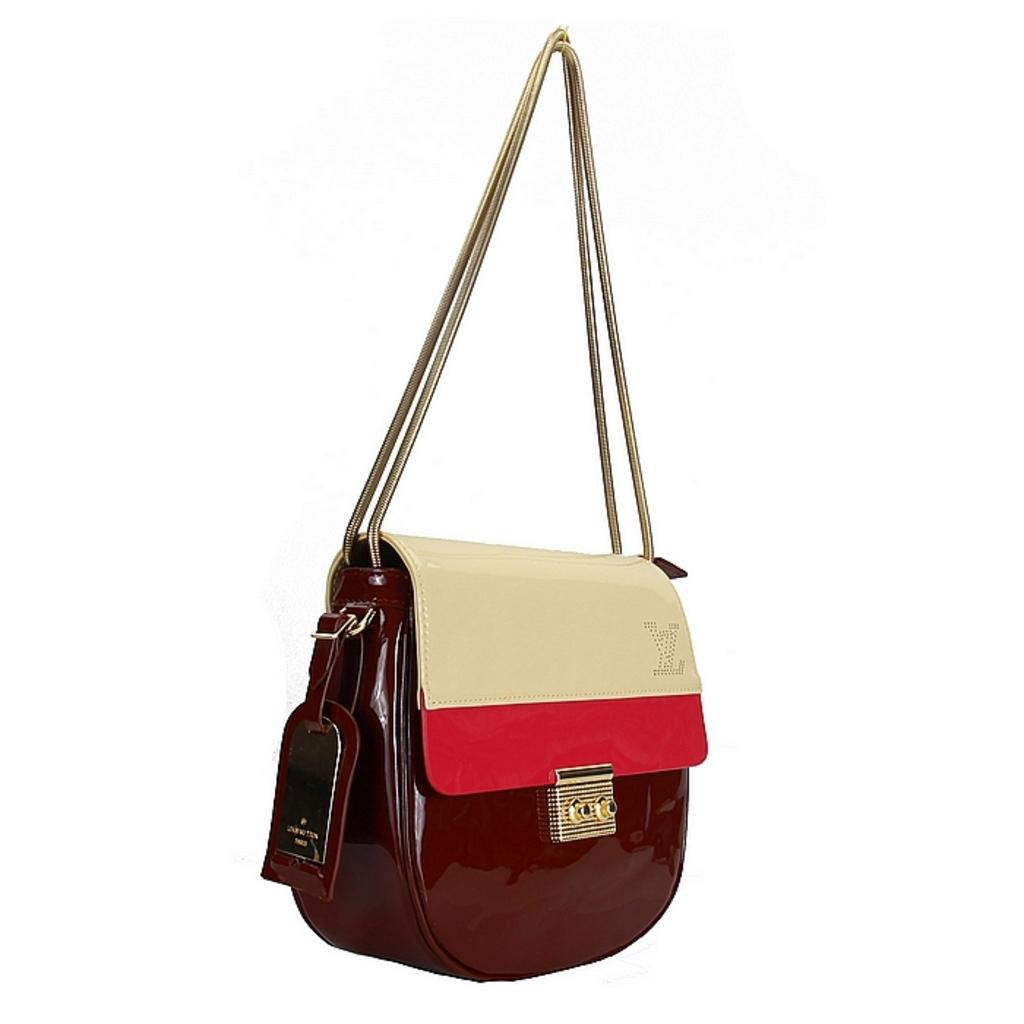What is the color of the handbag in the image? The handbag in the image is brown. What feature of the handbag allows it to be carried easily? The handbag has a strap that allows it to be carried easily. What additional feature can be seen on the handbag? The handbag has a clip. What type of business does the queen own, as seen in the image? There is no queen or business present in the image; it only features a brown handbag with a strap and a clip. 